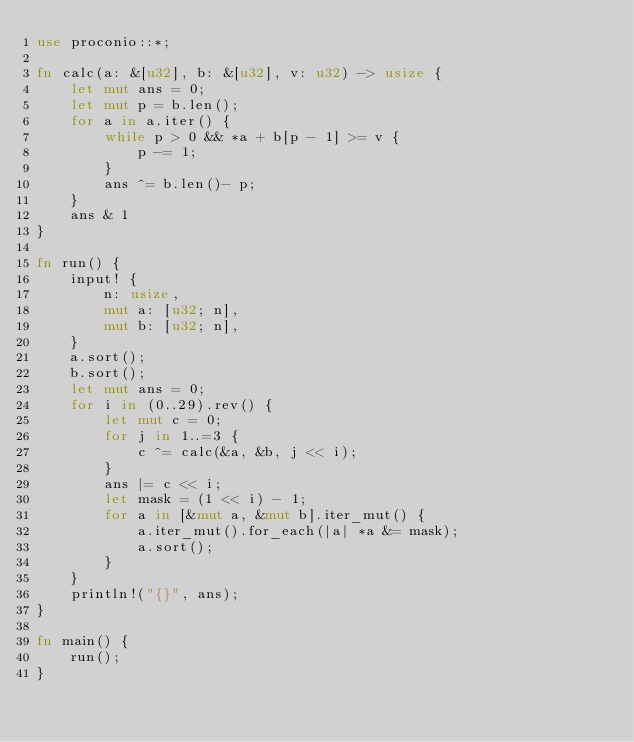Convert code to text. <code><loc_0><loc_0><loc_500><loc_500><_Rust_>use proconio::*;

fn calc(a: &[u32], b: &[u32], v: u32) -> usize {
    let mut ans = 0;
    let mut p = b.len();
    for a in a.iter() {
        while p > 0 && *a + b[p - 1] >= v {
            p -= 1;
        }
        ans ^= b.len()- p;
    }
    ans & 1
}

fn run() {
    input! {
        n: usize,
        mut a: [u32; n],
        mut b: [u32; n],
    }
    a.sort();
    b.sort();
    let mut ans = 0;
    for i in (0..29).rev() {
        let mut c = 0;
        for j in 1..=3 {
            c ^= calc(&a, &b, j << i);
        }
        ans |= c << i;
        let mask = (1 << i) - 1;
        for a in [&mut a, &mut b].iter_mut() {
            a.iter_mut().for_each(|a| *a &= mask);
            a.sort();
        }
    }
    println!("{}", ans);
}

fn main() {
    run();
}
</code> 